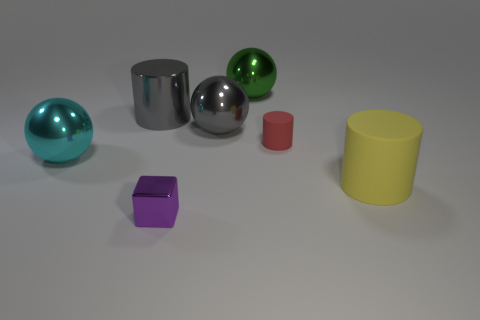Add 2 tiny purple spheres. How many objects exist? 9 Subtract all blocks. How many objects are left? 6 Subtract 0 red blocks. How many objects are left? 7 Subtract all metallic cubes. Subtract all big metal cylinders. How many objects are left? 5 Add 5 cyan metal spheres. How many cyan metal spheres are left? 6 Add 2 purple blocks. How many purple blocks exist? 3 